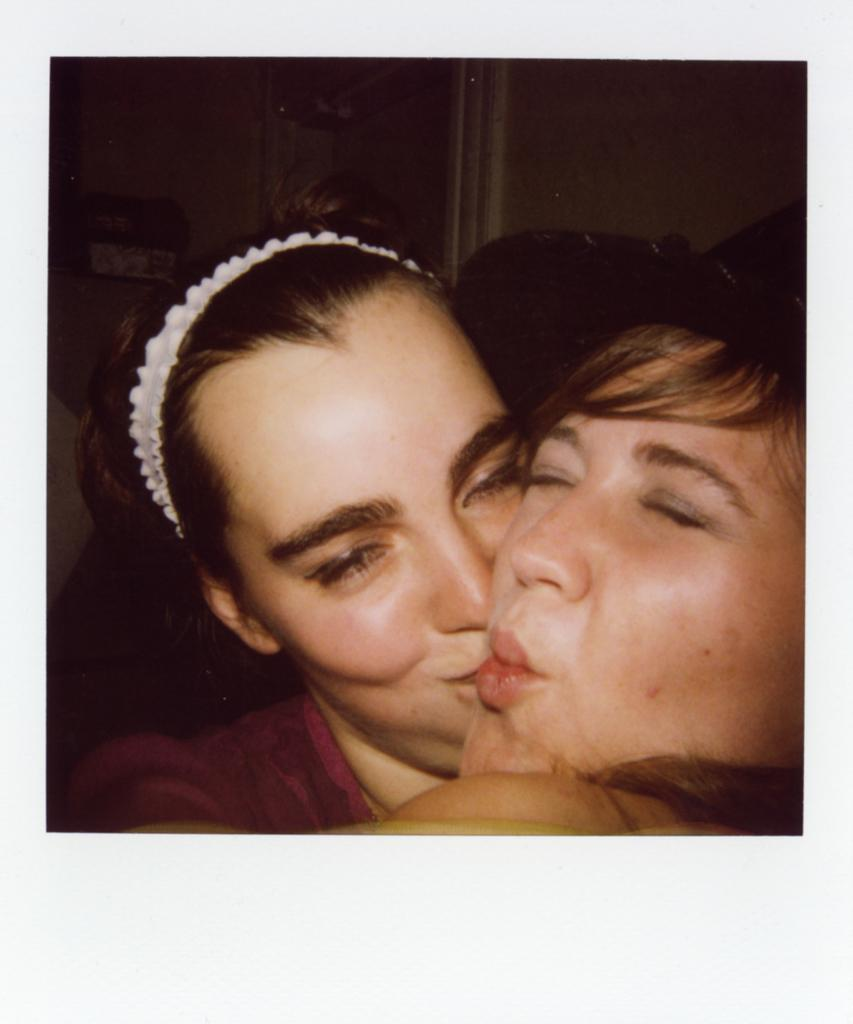How many people are in the image? There are two persons in the image. What is one of the persons wearing on their head? One of the persons is wearing a cap. What type of accessory is present on the head of the other person? There is a white-colored hairband on the head of one of the persons. What type of pen is being used by one of the persons in the image? There is no pen present in the image. What liquid is being poured by one of the persons in the image? There is no liquid being poured in the image. 